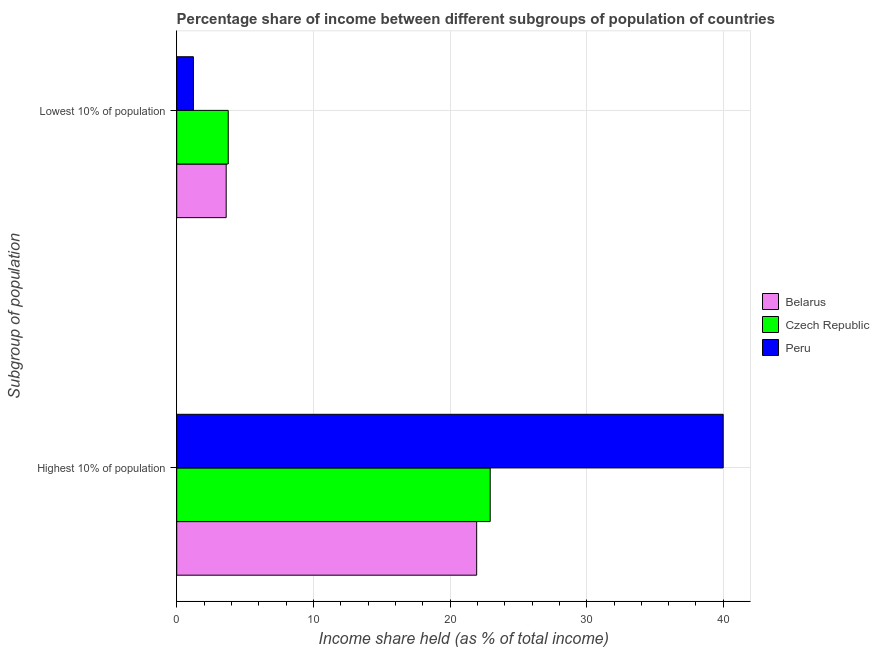How many groups of bars are there?
Make the answer very short. 2. Are the number of bars on each tick of the Y-axis equal?
Give a very brief answer. Yes. How many bars are there on the 2nd tick from the top?
Provide a short and direct response. 3. What is the label of the 2nd group of bars from the top?
Keep it short and to the point. Highest 10% of population. What is the income share held by lowest 10% of the population in Belarus?
Offer a terse response. 3.62. Across all countries, what is the maximum income share held by lowest 10% of the population?
Your response must be concise. 3.77. Across all countries, what is the minimum income share held by highest 10% of the population?
Make the answer very short. 21.95. In which country was the income share held by lowest 10% of the population maximum?
Offer a very short reply. Czech Republic. In which country was the income share held by lowest 10% of the population minimum?
Make the answer very short. Peru. What is the total income share held by lowest 10% of the population in the graph?
Your answer should be very brief. 8.61. What is the difference between the income share held by highest 10% of the population in Czech Republic and that in Peru?
Give a very brief answer. -17.05. What is the difference between the income share held by highest 10% of the population in Peru and the income share held by lowest 10% of the population in Czech Republic?
Give a very brief answer. 36.22. What is the average income share held by highest 10% of the population per country?
Provide a succinct answer. 28.29. What is the difference between the income share held by lowest 10% of the population and income share held by highest 10% of the population in Belarus?
Your answer should be compact. -18.33. What is the ratio of the income share held by highest 10% of the population in Czech Republic to that in Belarus?
Make the answer very short. 1.05. Is the income share held by highest 10% of the population in Belarus less than that in Peru?
Offer a terse response. Yes. What does the 2nd bar from the top in Lowest 10% of population represents?
Make the answer very short. Czech Republic. What does the 2nd bar from the bottom in Highest 10% of population represents?
Make the answer very short. Czech Republic. How many bars are there?
Provide a short and direct response. 6. Are all the bars in the graph horizontal?
Offer a very short reply. Yes. How many countries are there in the graph?
Make the answer very short. 3. Are the values on the major ticks of X-axis written in scientific E-notation?
Keep it short and to the point. No. Does the graph contain any zero values?
Provide a succinct answer. No. Does the graph contain grids?
Your answer should be compact. Yes. Where does the legend appear in the graph?
Make the answer very short. Center right. How many legend labels are there?
Keep it short and to the point. 3. How are the legend labels stacked?
Make the answer very short. Vertical. What is the title of the graph?
Provide a short and direct response. Percentage share of income between different subgroups of population of countries. Does "Malaysia" appear as one of the legend labels in the graph?
Your answer should be very brief. No. What is the label or title of the X-axis?
Provide a succinct answer. Income share held (as % of total income). What is the label or title of the Y-axis?
Offer a terse response. Subgroup of population. What is the Income share held (as % of total income) in Belarus in Highest 10% of population?
Provide a succinct answer. 21.95. What is the Income share held (as % of total income) of Czech Republic in Highest 10% of population?
Your response must be concise. 22.94. What is the Income share held (as % of total income) in Peru in Highest 10% of population?
Offer a very short reply. 39.99. What is the Income share held (as % of total income) in Belarus in Lowest 10% of population?
Your answer should be very brief. 3.62. What is the Income share held (as % of total income) of Czech Republic in Lowest 10% of population?
Give a very brief answer. 3.77. What is the Income share held (as % of total income) in Peru in Lowest 10% of population?
Keep it short and to the point. 1.22. Across all Subgroup of population, what is the maximum Income share held (as % of total income) in Belarus?
Provide a short and direct response. 21.95. Across all Subgroup of population, what is the maximum Income share held (as % of total income) of Czech Republic?
Provide a short and direct response. 22.94. Across all Subgroup of population, what is the maximum Income share held (as % of total income) of Peru?
Give a very brief answer. 39.99. Across all Subgroup of population, what is the minimum Income share held (as % of total income) of Belarus?
Make the answer very short. 3.62. Across all Subgroup of population, what is the minimum Income share held (as % of total income) in Czech Republic?
Your response must be concise. 3.77. Across all Subgroup of population, what is the minimum Income share held (as % of total income) of Peru?
Your answer should be very brief. 1.22. What is the total Income share held (as % of total income) in Belarus in the graph?
Give a very brief answer. 25.57. What is the total Income share held (as % of total income) in Czech Republic in the graph?
Your answer should be compact. 26.71. What is the total Income share held (as % of total income) in Peru in the graph?
Your answer should be very brief. 41.21. What is the difference between the Income share held (as % of total income) of Belarus in Highest 10% of population and that in Lowest 10% of population?
Ensure brevity in your answer.  18.33. What is the difference between the Income share held (as % of total income) of Czech Republic in Highest 10% of population and that in Lowest 10% of population?
Keep it short and to the point. 19.17. What is the difference between the Income share held (as % of total income) in Peru in Highest 10% of population and that in Lowest 10% of population?
Give a very brief answer. 38.77. What is the difference between the Income share held (as % of total income) in Belarus in Highest 10% of population and the Income share held (as % of total income) in Czech Republic in Lowest 10% of population?
Ensure brevity in your answer.  18.18. What is the difference between the Income share held (as % of total income) in Belarus in Highest 10% of population and the Income share held (as % of total income) in Peru in Lowest 10% of population?
Make the answer very short. 20.73. What is the difference between the Income share held (as % of total income) of Czech Republic in Highest 10% of population and the Income share held (as % of total income) of Peru in Lowest 10% of population?
Offer a terse response. 21.72. What is the average Income share held (as % of total income) of Belarus per Subgroup of population?
Ensure brevity in your answer.  12.79. What is the average Income share held (as % of total income) of Czech Republic per Subgroup of population?
Give a very brief answer. 13.36. What is the average Income share held (as % of total income) of Peru per Subgroup of population?
Your answer should be very brief. 20.61. What is the difference between the Income share held (as % of total income) of Belarus and Income share held (as % of total income) of Czech Republic in Highest 10% of population?
Offer a very short reply. -0.99. What is the difference between the Income share held (as % of total income) of Belarus and Income share held (as % of total income) of Peru in Highest 10% of population?
Ensure brevity in your answer.  -18.04. What is the difference between the Income share held (as % of total income) of Czech Republic and Income share held (as % of total income) of Peru in Highest 10% of population?
Keep it short and to the point. -17.05. What is the difference between the Income share held (as % of total income) in Belarus and Income share held (as % of total income) in Czech Republic in Lowest 10% of population?
Provide a short and direct response. -0.15. What is the difference between the Income share held (as % of total income) of Czech Republic and Income share held (as % of total income) of Peru in Lowest 10% of population?
Give a very brief answer. 2.55. What is the ratio of the Income share held (as % of total income) in Belarus in Highest 10% of population to that in Lowest 10% of population?
Your response must be concise. 6.06. What is the ratio of the Income share held (as % of total income) in Czech Republic in Highest 10% of population to that in Lowest 10% of population?
Make the answer very short. 6.08. What is the ratio of the Income share held (as % of total income) in Peru in Highest 10% of population to that in Lowest 10% of population?
Keep it short and to the point. 32.78. What is the difference between the highest and the second highest Income share held (as % of total income) of Belarus?
Make the answer very short. 18.33. What is the difference between the highest and the second highest Income share held (as % of total income) of Czech Republic?
Ensure brevity in your answer.  19.17. What is the difference between the highest and the second highest Income share held (as % of total income) of Peru?
Offer a very short reply. 38.77. What is the difference between the highest and the lowest Income share held (as % of total income) of Belarus?
Your answer should be compact. 18.33. What is the difference between the highest and the lowest Income share held (as % of total income) of Czech Republic?
Provide a short and direct response. 19.17. What is the difference between the highest and the lowest Income share held (as % of total income) of Peru?
Keep it short and to the point. 38.77. 